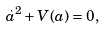Convert formula to latex. <formula><loc_0><loc_0><loc_500><loc_500>\dot { a } ^ { 2 } + V ( a ) = 0 ,</formula> 